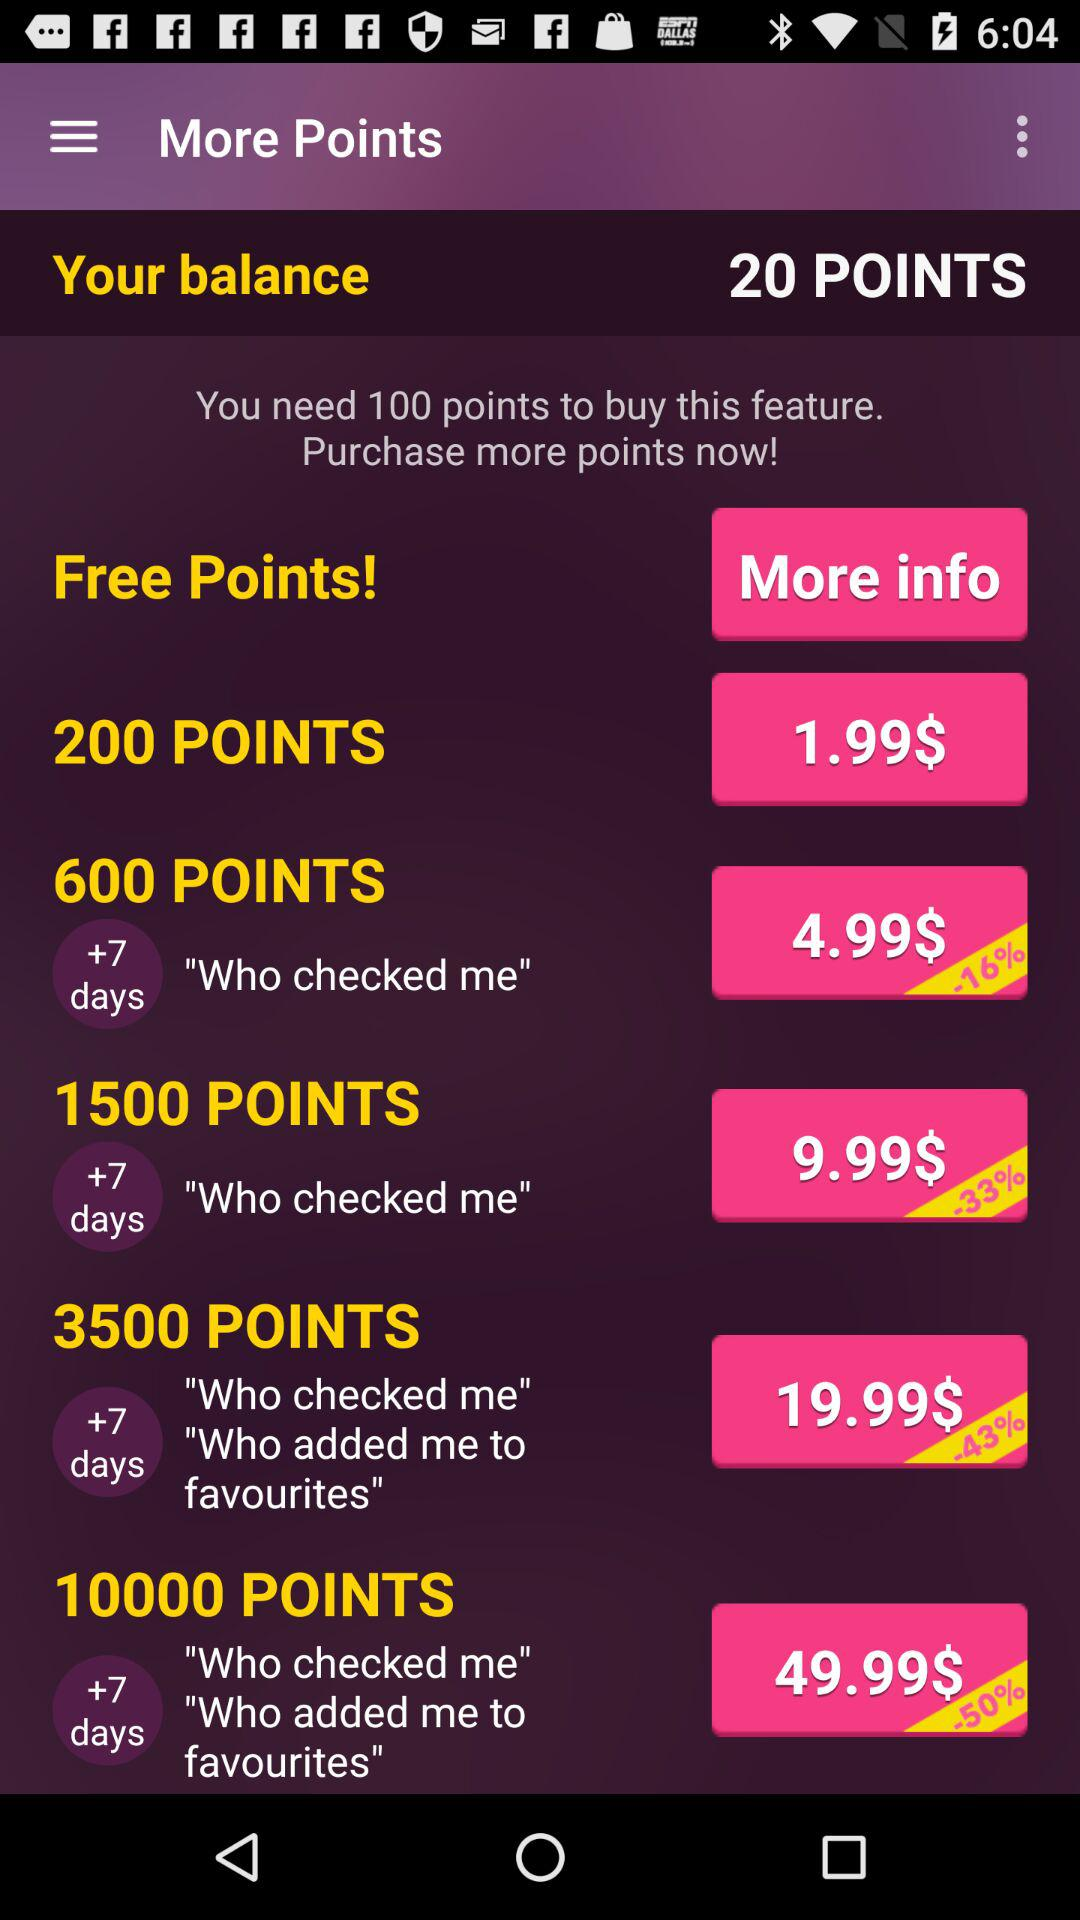On buying 3500 points, for how many days can I see "Who checked me" and "Who added me to favourites"? You can see for +7 days. 